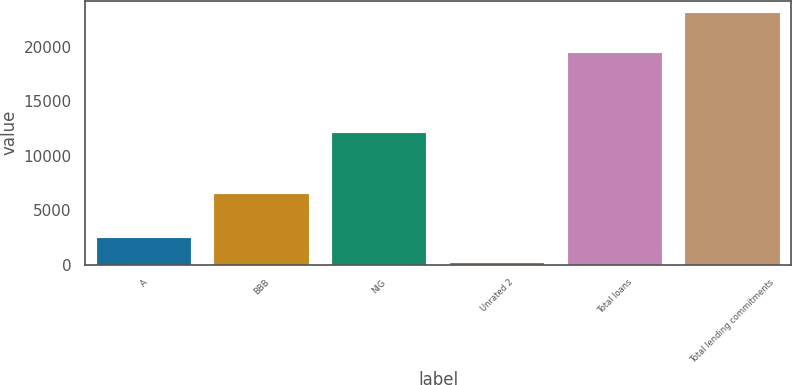Convert chart. <chart><loc_0><loc_0><loc_500><loc_500><bar_chart><fcel>A<fcel>BBB<fcel>NIG<fcel>Unrated 2<fcel>Total loans<fcel>Total lending commitments<nl><fcel>2424.6<fcel>6473<fcel>12114<fcel>126<fcel>19488<fcel>23112<nl></chart> 